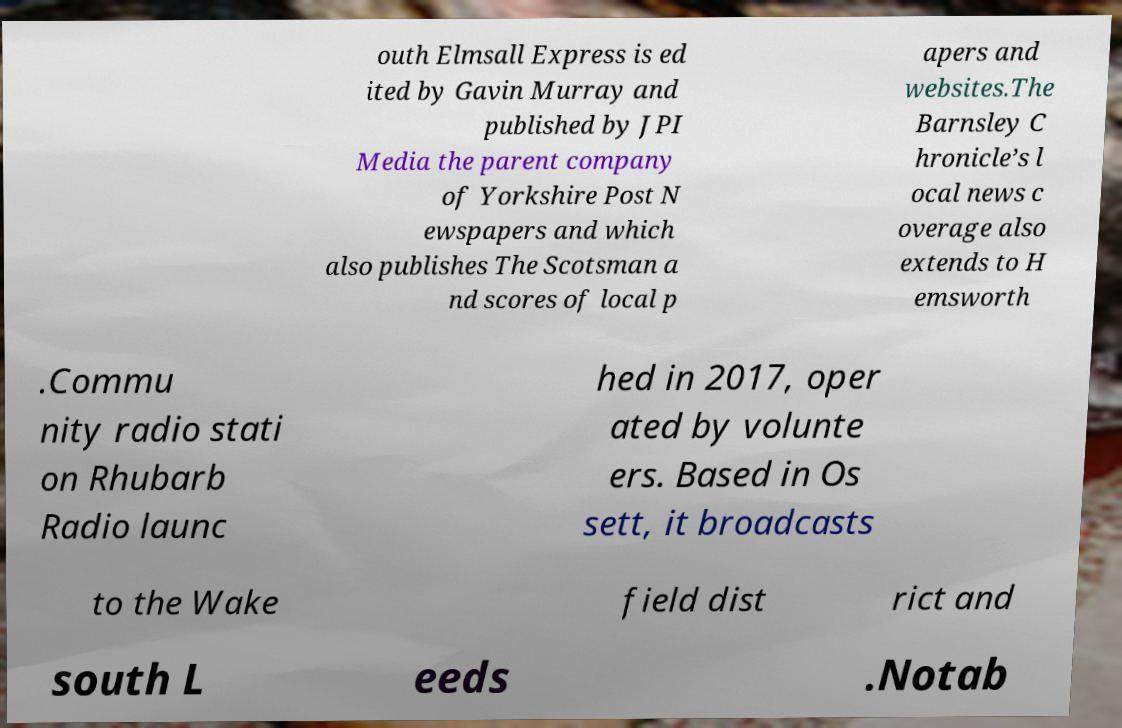There's text embedded in this image that I need extracted. Can you transcribe it verbatim? outh Elmsall Express is ed ited by Gavin Murray and published by JPI Media the parent company of Yorkshire Post N ewspapers and which also publishes The Scotsman a nd scores of local p apers and websites.The Barnsley C hronicle’s l ocal news c overage also extends to H emsworth .Commu nity radio stati on Rhubarb Radio launc hed in 2017, oper ated by volunte ers. Based in Os sett, it broadcasts to the Wake field dist rict and south L eeds .Notab 